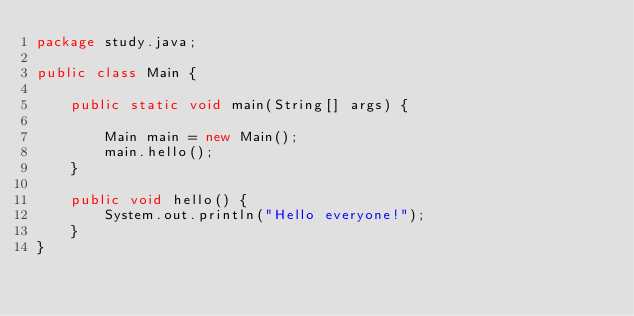Convert code to text. <code><loc_0><loc_0><loc_500><loc_500><_Java_>package study.java;

public class Main {

	public static void main(String[] args) {

		Main main = new Main();
		main.hello();
	}

	public void hello() {
		System.out.println("Hello everyone!");
	}
}
</code> 